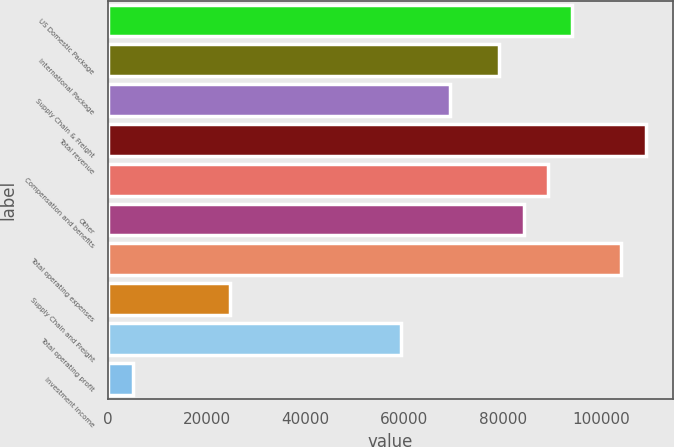Convert chart. <chart><loc_0><loc_0><loc_500><loc_500><bar_chart><fcel>US Domestic Package<fcel>International Package<fcel>Supply Chain & Freight<fcel>Total revenue<fcel>Compensation and benefits<fcel>Other<fcel>Total operating expenses<fcel>Supply Chain and Freight<fcel>Total operating profit<fcel>Investment income<nl><fcel>94133.8<fcel>79270.8<fcel>69362.2<fcel>108997<fcel>89179.5<fcel>84225.1<fcel>104042<fcel>24773.4<fcel>59453.6<fcel>4956.19<nl></chart> 